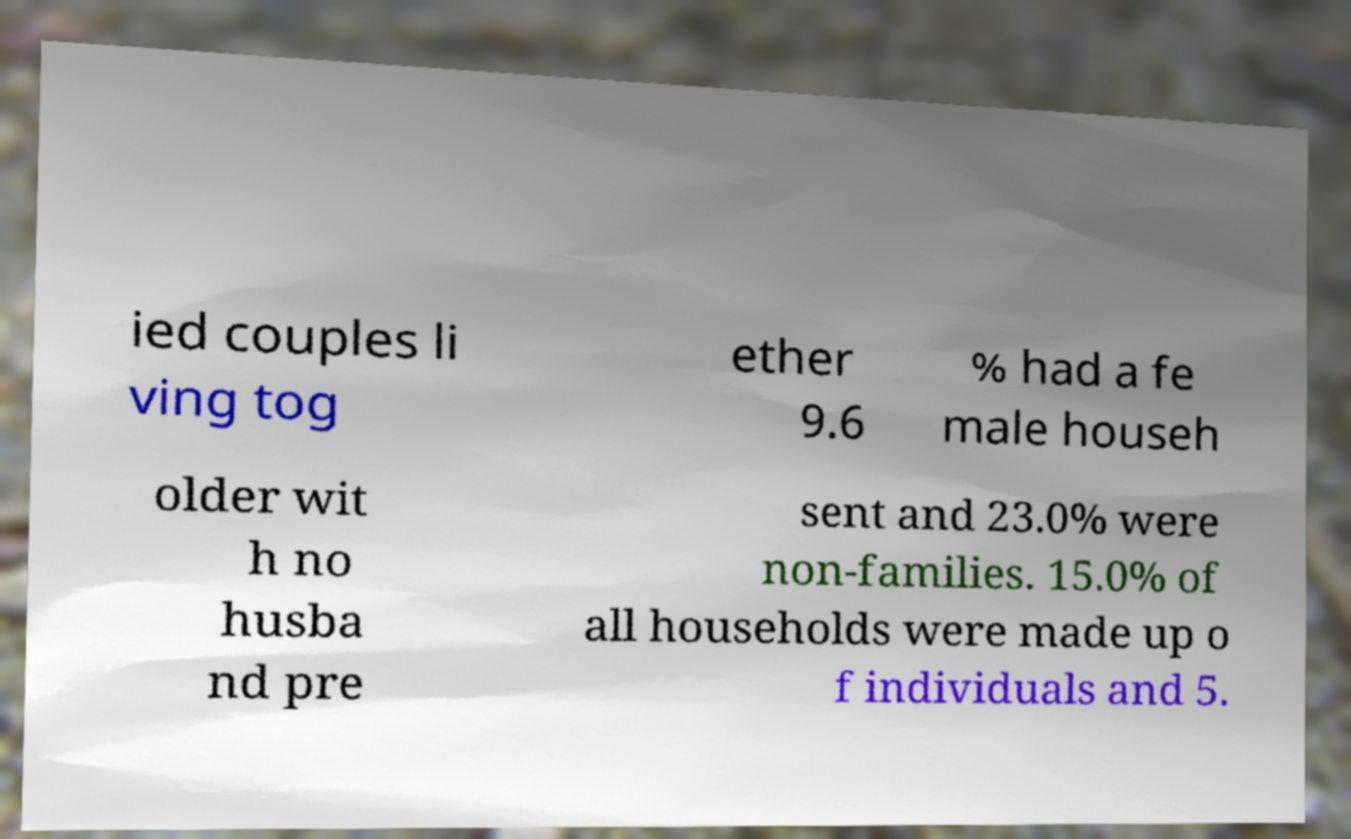Please identify and transcribe the text found in this image. ied couples li ving tog ether 9.6 % had a fe male househ older wit h no husba nd pre sent and 23.0% were non-families. 15.0% of all households were made up o f individuals and 5. 